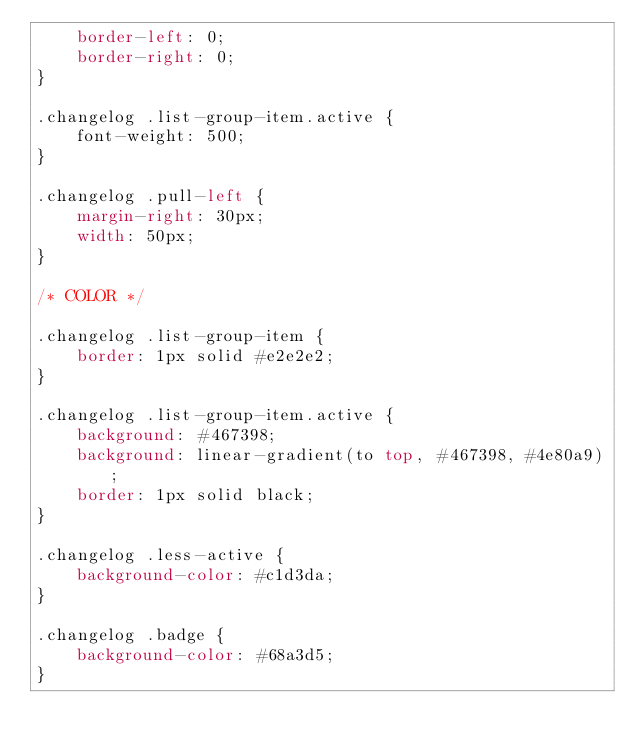<code> <loc_0><loc_0><loc_500><loc_500><_CSS_>    border-left: 0;
    border-right: 0;
}

.changelog .list-group-item.active {
    font-weight: 500;
}

.changelog .pull-left {
    margin-right: 30px;
    width: 50px;
}

/* COLOR */

.changelog .list-group-item {
    border: 1px solid #e2e2e2;
}

.changelog .list-group-item.active {
    background: #467398;
    background: linear-gradient(to top, #467398, #4e80a9);
    border: 1px solid black;
}

.changelog .less-active {
    background-color: #c1d3da;
}

.changelog .badge {
    background-color: #68a3d5;
}</code> 